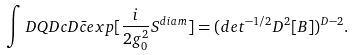Convert formula to latex. <formula><loc_0><loc_0><loc_500><loc_500>\int D Q D c D \bar { c } e x p [ \frac { i } { 2 g _ { 0 } ^ { 2 } } S ^ { d i a m } ] = ( d e t ^ { - 1 / 2 } D ^ { 2 } [ B ] ) ^ { D - 2 } .</formula> 